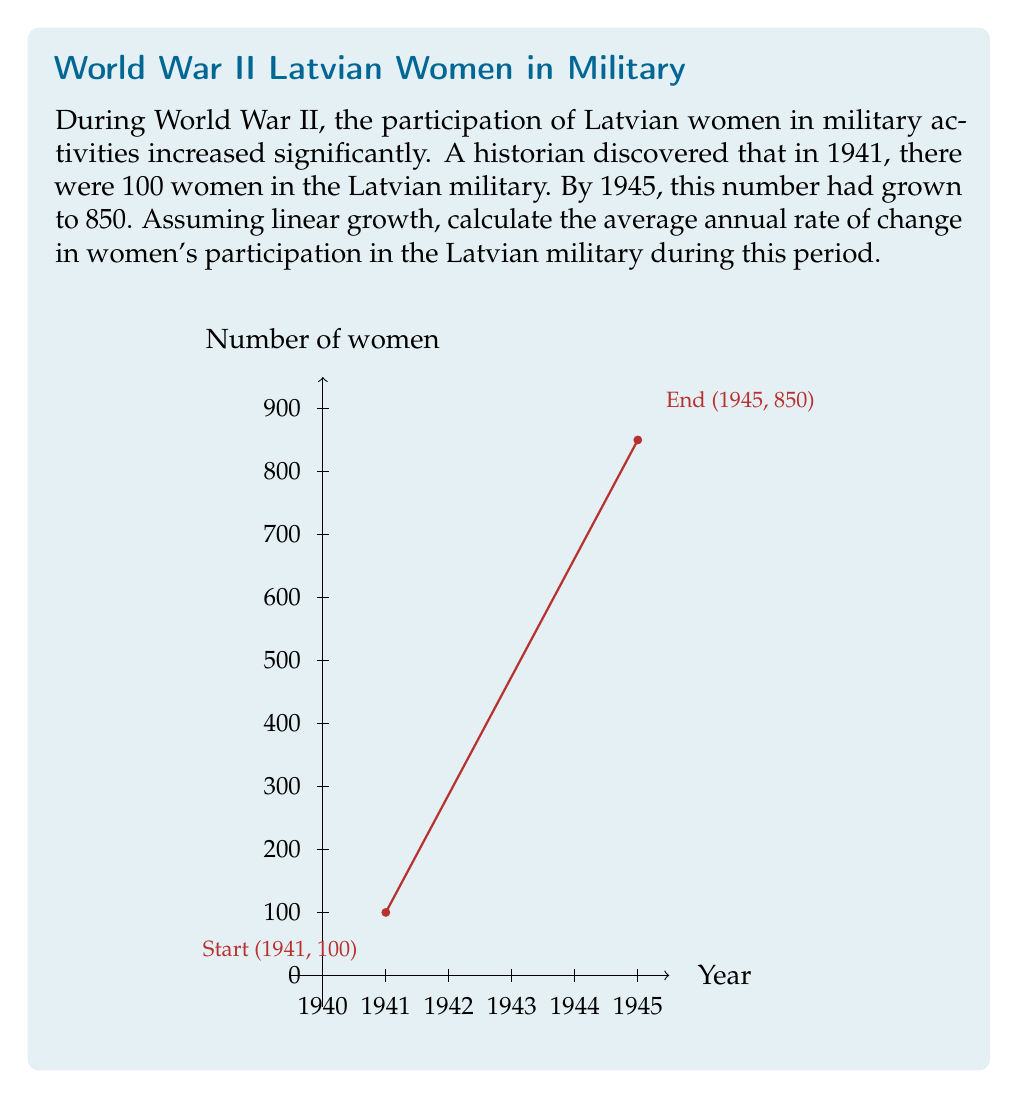Provide a solution to this math problem. To calculate the average annual rate of change, we need to follow these steps:

1) Identify the total change in the number of women:
   $$\text{Total change} = 850 - 100 = 750$$

2) Determine the time period:
   $$\text{Time period} = 1945 - 1941 = 4 \text{ years}$$

3) Calculate the average annual rate of change using the formula:
   $$\text{Rate of change} = \frac{\text{Total change}}{\text{Time period}}$$

4) Substitute the values:
   $$\text{Rate of change} = \frac{750}{4} = 187.5$$

Therefore, the average annual rate of change in women's participation in the Latvian military during World War II was 187.5 women per year.
Answer: 187.5 women/year 